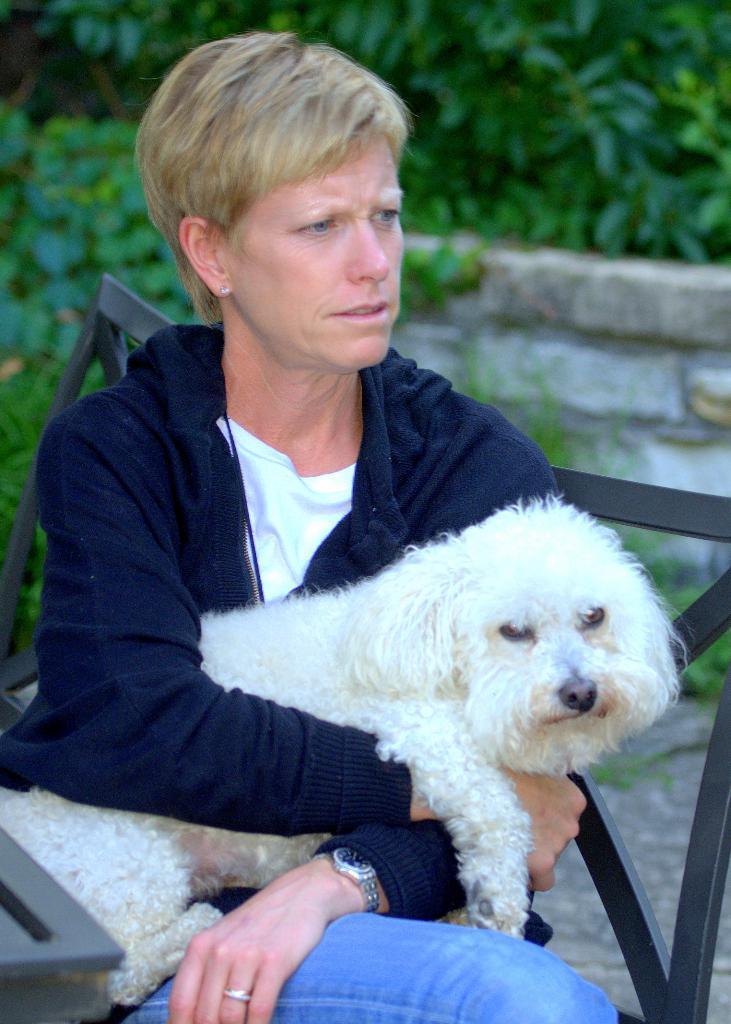Please provide a concise description of this image. In the center of the image we can see a person is sitting and she is holding a dog. At the bottom left side of the image, there is an object. In the background there is a wall and trees. 